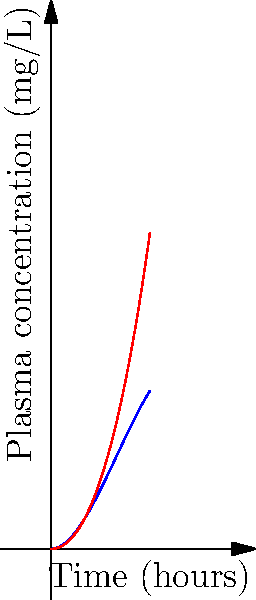The graph shows the plasma concentration over time for two different formulations (A and B) of a renal medication. Based on the polynomial curves, which formulation has higher bioavailability, and what characteristic of the curves supports this conclusion? To determine which formulation has higher bioavailability, we need to analyze the area under the curve (AUC) for each formulation, as AUC is directly proportional to bioavailability. Let's examine the characteristics of each curve:

1. Formulation A (blue curve):
   - Reaches a higher peak concentration
   - Has a steeper initial slope
   - Covers a larger area under the curve

2. Formulation B (red curve):
   - Has a lower peak concentration
   - Shows a more gradual increase and decrease
   - Covers a smaller area under the curve

The area under the curve (AUC) represents the total drug exposure over time. A larger AUC indicates higher bioavailability.

Formulation A has a visibly larger area under its curve compared to Formulation B. This is evident from:
a) The higher peak concentration
b) The overall higher position of the curve throughout most of the time range

Therefore, Formulation A has higher bioavailability. The characteristic that supports this conclusion is the larger area under the curve for Formulation A.
Answer: Formulation A has higher bioavailability due to its larger area under the curve. 